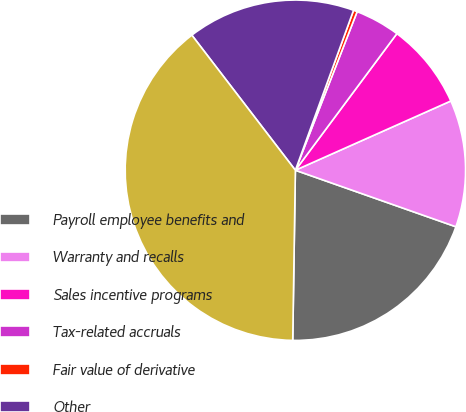Convert chart. <chart><loc_0><loc_0><loc_500><loc_500><pie_chart><fcel>Payroll employee benefits and<fcel>Warranty and recalls<fcel>Sales incentive programs<fcel>Tax-related accruals<fcel>Fair value of derivative<fcel>Other<fcel>Total accrued liabilities<nl><fcel>19.86%<fcel>12.06%<fcel>8.16%<fcel>4.26%<fcel>0.36%<fcel>15.96%<fcel>39.35%<nl></chart> 